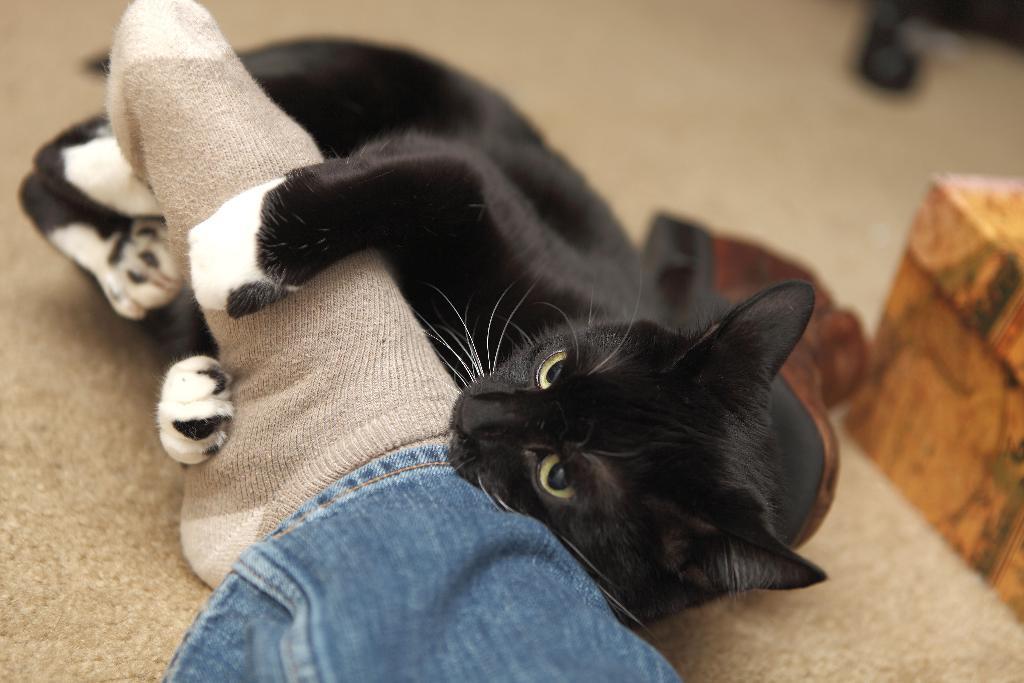In one or two sentences, can you explain what this image depicts? In this picture I can observe black color cat lying on the floor. Beside the cat I can observe human leg. The background is blurred. 